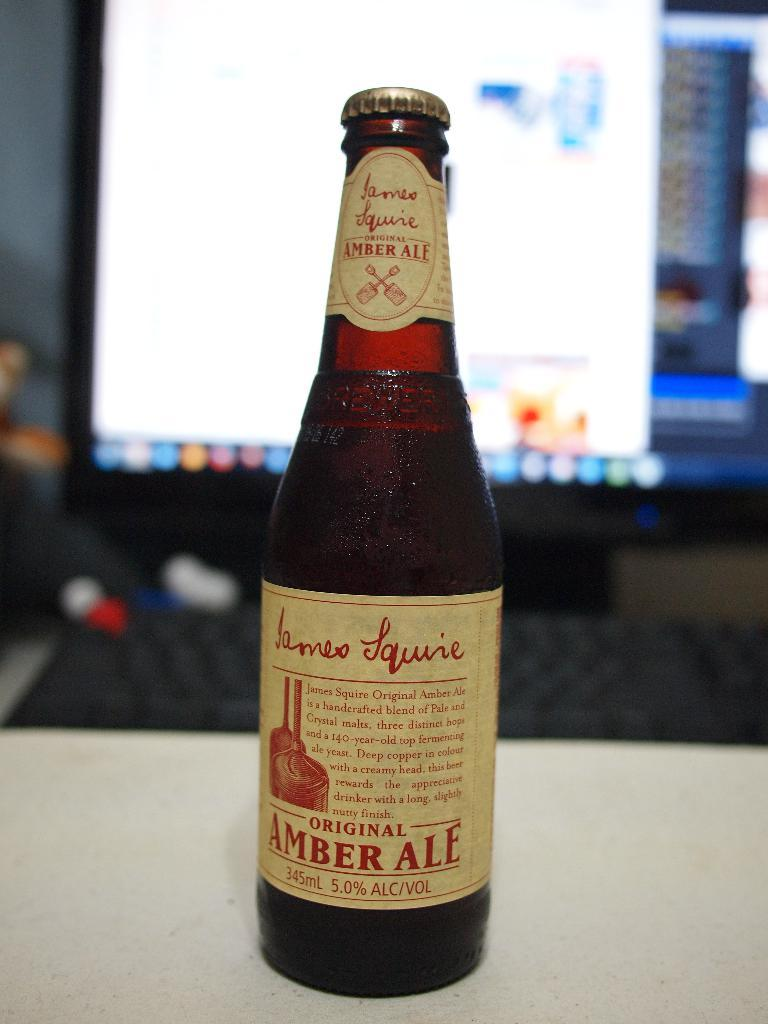<image>
Relay a brief, clear account of the picture shown. A bottle of amber ale has a tan and red label. 